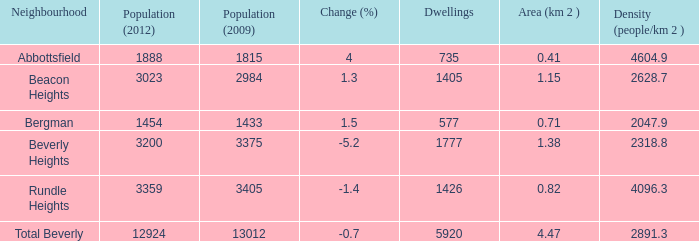How many homes in beverly heights have a change rate higher than - None. 